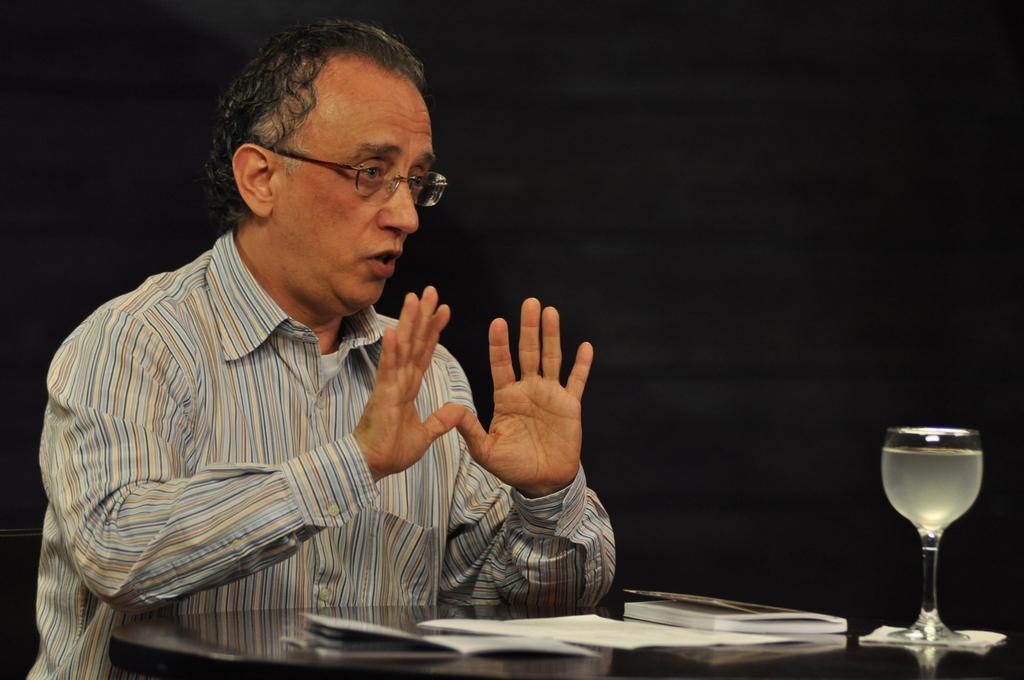Can you describe this image briefly? In this image there is a person, in front of the person there is a table. On the table there is a glass of drink, a book and papers. The background is dark. 